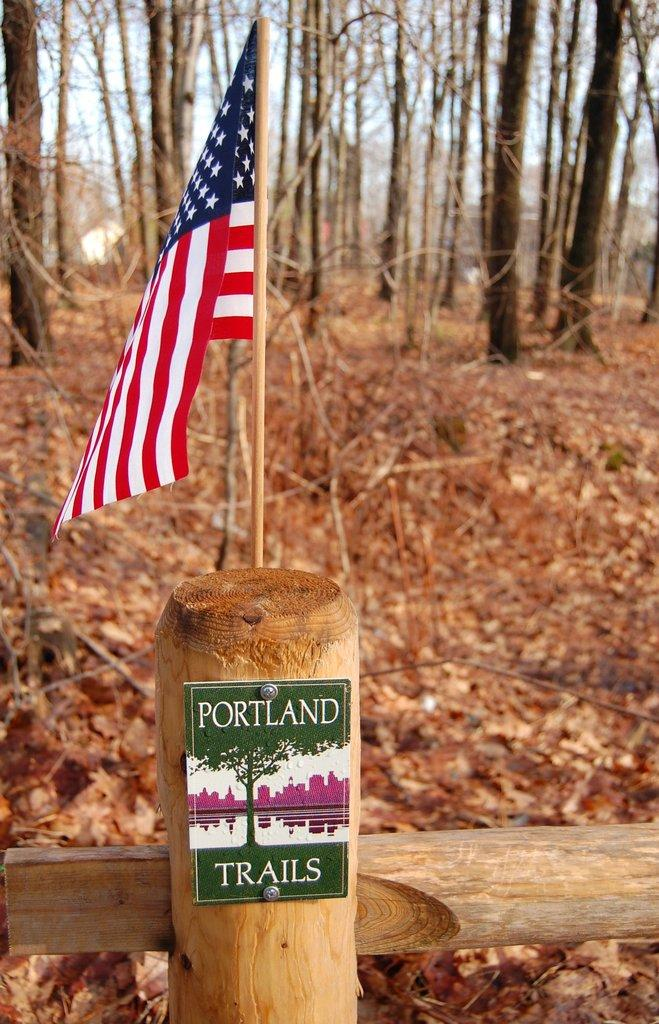What is located in front of the image? There is a flag in front of the image. What is attached to the wooden fence? There is a name board on the wooden fence. What can be seen behind the fence? There are trees behind the fence. What is present on the surface in the image? Dry leaves are present on the surface. Can you tell me how many times the word "bit" appears in the name board? There is no mention of the word "bit" in the image, as it only features a flag, a name board on a wooden fence, trees, and dry leaves. What type of class is being held in the image? There is no indication of a class being held in the image; it only contains a flag, a name board, trees, and dry leaves. 